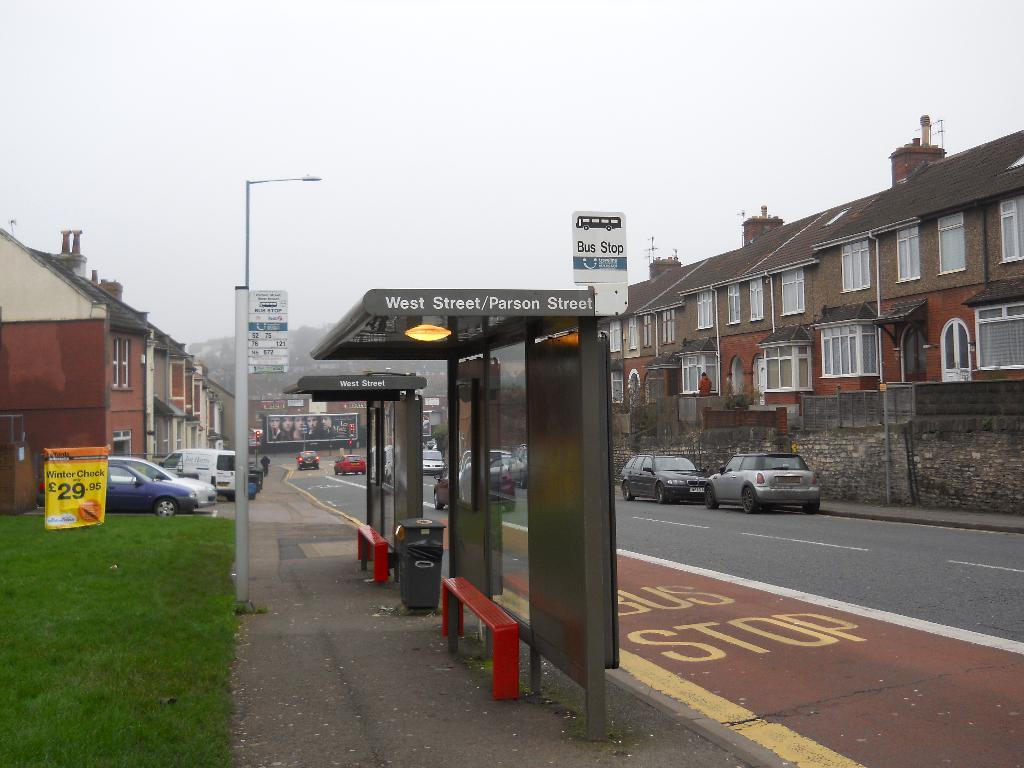<image>
Create a compact narrative representing the image presented. A covered bus stop at West Street and Parsons Street. 